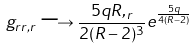Convert formula to latex. <formula><loc_0><loc_0><loc_500><loc_500>g _ { r r , r } \longrightarrow \frac { 5 q R , _ { r } } { 2 ( R - 2 ) ^ { 3 } } e ^ { \frac { 5 q } { 4 ( R - 2 ) } }</formula> 